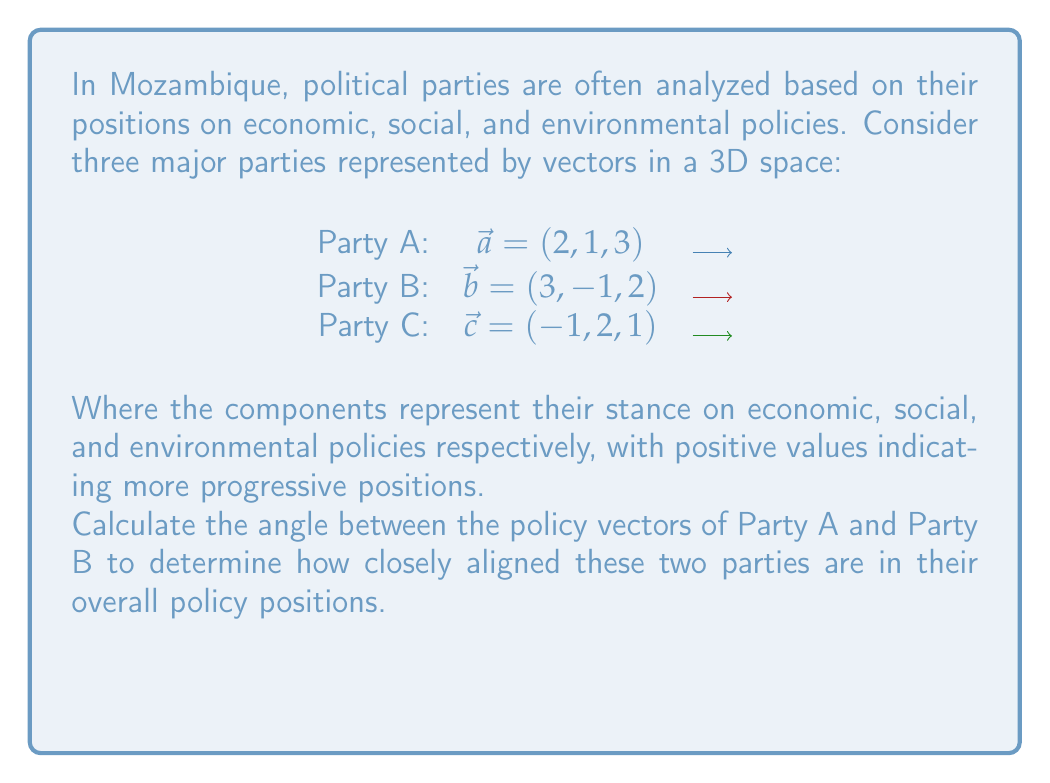Can you answer this question? To find the angle between two vectors, we can use the dot product formula:

$$\cos \theta = \frac{\vec{a} \cdot \vec{b}}{|\vec{a}||\vec{b}|}$$

Step 1: Calculate the dot product of $\vec{a}$ and $\vec{b}$:
$$\vec{a} \cdot \vec{b} = (2)(3) + (1)(-1) + (3)(2) = 6 - 1 + 6 = 11$$

Step 2: Calculate the magnitudes of $\vec{a}$ and $\vec{b}$:
$$|\vec{a}| = \sqrt{2^2 + 1^2 + 3^2} = \sqrt{4 + 1 + 9} = \sqrt{14}$$
$$|\vec{b}| = \sqrt{3^2 + (-1)^2 + 2^2} = \sqrt{9 + 1 + 4} = \sqrt{14}$$

Step 3: Substitute into the formula:
$$\cos \theta = \frac{11}{(\sqrt{14})(\sqrt{14})} = \frac{11}{14}$$

Step 4: Take the inverse cosine (arccos) of both sides:
$$\theta = \arccos(\frac{11}{14})$$

Step 5: Calculate the result:
$$\theta \approx 0.4115 \text{ radians} \approx 23.58°$$
Answer: $23.58°$ 